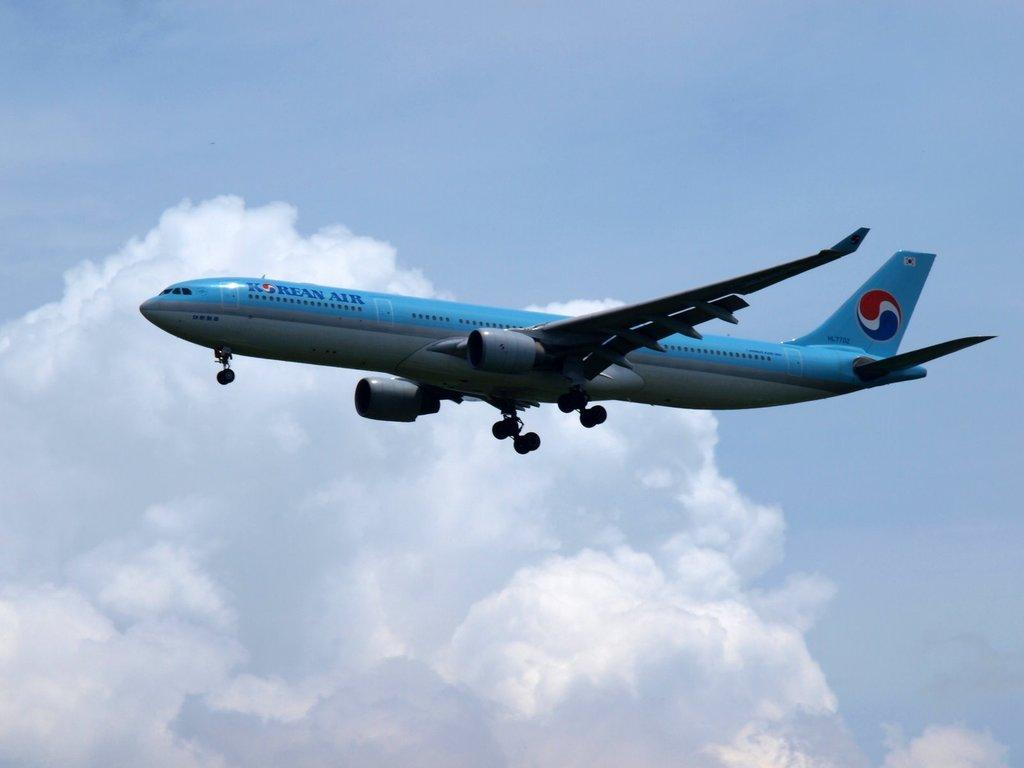Provide a one-sentence caption for the provided image. An airplane with the words Korean Air on it flying near a cloud. 